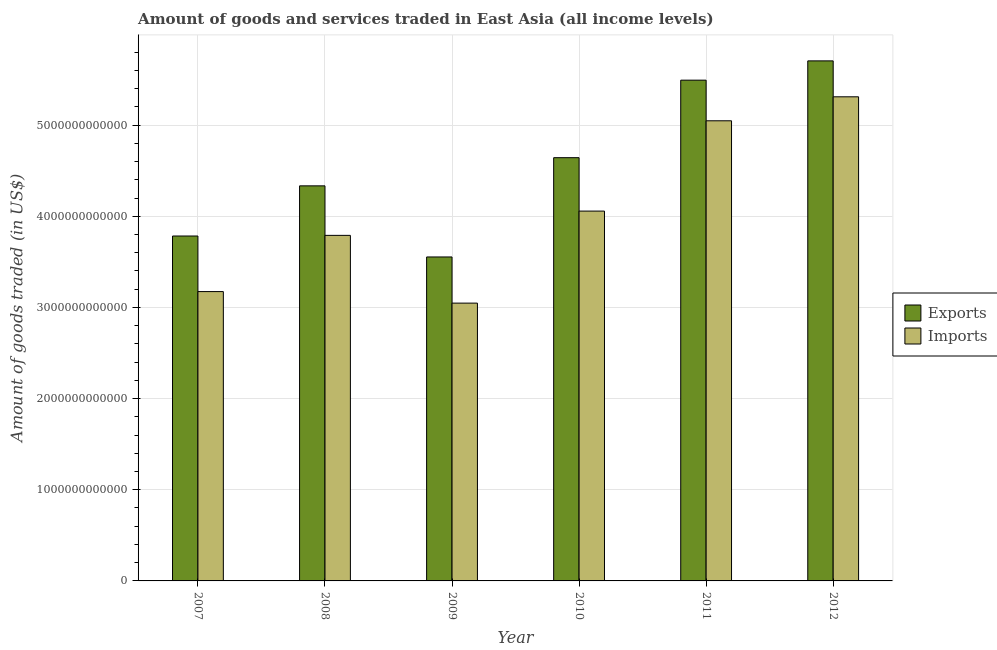How many bars are there on the 5th tick from the left?
Ensure brevity in your answer.  2. How many bars are there on the 6th tick from the right?
Make the answer very short. 2. What is the amount of goods exported in 2008?
Offer a terse response. 4.33e+12. Across all years, what is the maximum amount of goods imported?
Offer a terse response. 5.31e+12. Across all years, what is the minimum amount of goods imported?
Ensure brevity in your answer.  3.05e+12. In which year was the amount of goods imported minimum?
Offer a very short reply. 2009. What is the total amount of goods exported in the graph?
Offer a very short reply. 2.75e+13. What is the difference between the amount of goods imported in 2007 and that in 2011?
Give a very brief answer. -1.87e+12. What is the difference between the amount of goods imported in 2007 and the amount of goods exported in 2009?
Provide a short and direct response. 1.26e+11. What is the average amount of goods imported per year?
Your response must be concise. 4.07e+12. In how many years, is the amount of goods imported greater than 5400000000000 US$?
Give a very brief answer. 0. What is the ratio of the amount of goods imported in 2008 to that in 2009?
Make the answer very short. 1.24. Is the amount of goods imported in 2007 less than that in 2012?
Your answer should be very brief. Yes. What is the difference between the highest and the second highest amount of goods exported?
Ensure brevity in your answer.  2.12e+11. What is the difference between the highest and the lowest amount of goods exported?
Provide a short and direct response. 2.15e+12. In how many years, is the amount of goods exported greater than the average amount of goods exported taken over all years?
Provide a short and direct response. 3. What does the 2nd bar from the left in 2008 represents?
Your response must be concise. Imports. What does the 2nd bar from the right in 2011 represents?
Your response must be concise. Exports. Are all the bars in the graph horizontal?
Offer a very short reply. No. What is the difference between two consecutive major ticks on the Y-axis?
Ensure brevity in your answer.  1.00e+12. Are the values on the major ticks of Y-axis written in scientific E-notation?
Ensure brevity in your answer.  No. Does the graph contain any zero values?
Your answer should be compact. No. Where does the legend appear in the graph?
Offer a terse response. Center right. What is the title of the graph?
Offer a very short reply. Amount of goods and services traded in East Asia (all income levels). What is the label or title of the Y-axis?
Provide a succinct answer. Amount of goods traded (in US$). What is the Amount of goods traded (in US$) in Exports in 2007?
Offer a terse response. 3.78e+12. What is the Amount of goods traded (in US$) in Imports in 2007?
Ensure brevity in your answer.  3.17e+12. What is the Amount of goods traded (in US$) of Exports in 2008?
Ensure brevity in your answer.  4.33e+12. What is the Amount of goods traded (in US$) in Imports in 2008?
Your answer should be very brief. 3.79e+12. What is the Amount of goods traded (in US$) of Exports in 2009?
Ensure brevity in your answer.  3.55e+12. What is the Amount of goods traded (in US$) in Imports in 2009?
Ensure brevity in your answer.  3.05e+12. What is the Amount of goods traded (in US$) of Exports in 2010?
Provide a short and direct response. 4.64e+12. What is the Amount of goods traded (in US$) in Imports in 2010?
Provide a short and direct response. 4.06e+12. What is the Amount of goods traded (in US$) in Exports in 2011?
Offer a terse response. 5.49e+12. What is the Amount of goods traded (in US$) of Imports in 2011?
Your response must be concise. 5.05e+12. What is the Amount of goods traded (in US$) in Exports in 2012?
Provide a short and direct response. 5.70e+12. What is the Amount of goods traded (in US$) of Imports in 2012?
Ensure brevity in your answer.  5.31e+12. Across all years, what is the maximum Amount of goods traded (in US$) in Exports?
Provide a short and direct response. 5.70e+12. Across all years, what is the maximum Amount of goods traded (in US$) of Imports?
Your answer should be compact. 5.31e+12. Across all years, what is the minimum Amount of goods traded (in US$) of Exports?
Provide a succinct answer. 3.55e+12. Across all years, what is the minimum Amount of goods traded (in US$) in Imports?
Make the answer very short. 3.05e+12. What is the total Amount of goods traded (in US$) of Exports in the graph?
Offer a very short reply. 2.75e+13. What is the total Amount of goods traded (in US$) in Imports in the graph?
Your answer should be very brief. 2.44e+13. What is the difference between the Amount of goods traded (in US$) of Exports in 2007 and that in 2008?
Offer a terse response. -5.50e+11. What is the difference between the Amount of goods traded (in US$) in Imports in 2007 and that in 2008?
Offer a terse response. -6.17e+11. What is the difference between the Amount of goods traded (in US$) of Exports in 2007 and that in 2009?
Provide a succinct answer. 2.30e+11. What is the difference between the Amount of goods traded (in US$) in Imports in 2007 and that in 2009?
Your response must be concise. 1.26e+11. What is the difference between the Amount of goods traded (in US$) of Exports in 2007 and that in 2010?
Your response must be concise. -8.59e+11. What is the difference between the Amount of goods traded (in US$) of Imports in 2007 and that in 2010?
Keep it short and to the point. -8.83e+11. What is the difference between the Amount of goods traded (in US$) in Exports in 2007 and that in 2011?
Make the answer very short. -1.71e+12. What is the difference between the Amount of goods traded (in US$) in Imports in 2007 and that in 2011?
Offer a terse response. -1.87e+12. What is the difference between the Amount of goods traded (in US$) in Exports in 2007 and that in 2012?
Offer a terse response. -1.92e+12. What is the difference between the Amount of goods traded (in US$) of Imports in 2007 and that in 2012?
Offer a very short reply. -2.14e+12. What is the difference between the Amount of goods traded (in US$) of Exports in 2008 and that in 2009?
Provide a succinct answer. 7.80e+11. What is the difference between the Amount of goods traded (in US$) in Imports in 2008 and that in 2009?
Give a very brief answer. 7.43e+11. What is the difference between the Amount of goods traded (in US$) of Exports in 2008 and that in 2010?
Offer a terse response. -3.09e+11. What is the difference between the Amount of goods traded (in US$) in Imports in 2008 and that in 2010?
Ensure brevity in your answer.  -2.66e+11. What is the difference between the Amount of goods traded (in US$) of Exports in 2008 and that in 2011?
Your response must be concise. -1.16e+12. What is the difference between the Amount of goods traded (in US$) of Imports in 2008 and that in 2011?
Your response must be concise. -1.26e+12. What is the difference between the Amount of goods traded (in US$) in Exports in 2008 and that in 2012?
Your response must be concise. -1.37e+12. What is the difference between the Amount of goods traded (in US$) in Imports in 2008 and that in 2012?
Offer a terse response. -1.52e+12. What is the difference between the Amount of goods traded (in US$) in Exports in 2009 and that in 2010?
Your response must be concise. -1.09e+12. What is the difference between the Amount of goods traded (in US$) in Imports in 2009 and that in 2010?
Make the answer very short. -1.01e+12. What is the difference between the Amount of goods traded (in US$) of Exports in 2009 and that in 2011?
Offer a terse response. -1.94e+12. What is the difference between the Amount of goods traded (in US$) in Imports in 2009 and that in 2011?
Your answer should be compact. -2.00e+12. What is the difference between the Amount of goods traded (in US$) in Exports in 2009 and that in 2012?
Provide a succinct answer. -2.15e+12. What is the difference between the Amount of goods traded (in US$) in Imports in 2009 and that in 2012?
Make the answer very short. -2.26e+12. What is the difference between the Amount of goods traded (in US$) of Exports in 2010 and that in 2011?
Keep it short and to the point. -8.50e+11. What is the difference between the Amount of goods traded (in US$) of Imports in 2010 and that in 2011?
Make the answer very short. -9.90e+11. What is the difference between the Amount of goods traded (in US$) in Exports in 2010 and that in 2012?
Your answer should be very brief. -1.06e+12. What is the difference between the Amount of goods traded (in US$) in Imports in 2010 and that in 2012?
Make the answer very short. -1.25e+12. What is the difference between the Amount of goods traded (in US$) of Exports in 2011 and that in 2012?
Keep it short and to the point. -2.12e+11. What is the difference between the Amount of goods traded (in US$) in Imports in 2011 and that in 2012?
Your response must be concise. -2.63e+11. What is the difference between the Amount of goods traded (in US$) in Exports in 2007 and the Amount of goods traded (in US$) in Imports in 2008?
Make the answer very short. -7.04e+09. What is the difference between the Amount of goods traded (in US$) of Exports in 2007 and the Amount of goods traded (in US$) of Imports in 2009?
Your answer should be compact. 7.36e+11. What is the difference between the Amount of goods traded (in US$) of Exports in 2007 and the Amount of goods traded (in US$) of Imports in 2010?
Your response must be concise. -2.74e+11. What is the difference between the Amount of goods traded (in US$) in Exports in 2007 and the Amount of goods traded (in US$) in Imports in 2011?
Provide a short and direct response. -1.26e+12. What is the difference between the Amount of goods traded (in US$) in Exports in 2007 and the Amount of goods traded (in US$) in Imports in 2012?
Keep it short and to the point. -1.53e+12. What is the difference between the Amount of goods traded (in US$) of Exports in 2008 and the Amount of goods traded (in US$) of Imports in 2009?
Your answer should be very brief. 1.29e+12. What is the difference between the Amount of goods traded (in US$) of Exports in 2008 and the Amount of goods traded (in US$) of Imports in 2010?
Keep it short and to the point. 2.77e+11. What is the difference between the Amount of goods traded (in US$) of Exports in 2008 and the Amount of goods traded (in US$) of Imports in 2011?
Your answer should be compact. -7.14e+11. What is the difference between the Amount of goods traded (in US$) in Exports in 2008 and the Amount of goods traded (in US$) in Imports in 2012?
Offer a terse response. -9.77e+11. What is the difference between the Amount of goods traded (in US$) in Exports in 2009 and the Amount of goods traded (in US$) in Imports in 2010?
Offer a very short reply. -5.03e+11. What is the difference between the Amount of goods traded (in US$) of Exports in 2009 and the Amount of goods traded (in US$) of Imports in 2011?
Your response must be concise. -1.49e+12. What is the difference between the Amount of goods traded (in US$) in Exports in 2009 and the Amount of goods traded (in US$) in Imports in 2012?
Ensure brevity in your answer.  -1.76e+12. What is the difference between the Amount of goods traded (in US$) in Exports in 2010 and the Amount of goods traded (in US$) in Imports in 2011?
Offer a very short reply. -4.05e+11. What is the difference between the Amount of goods traded (in US$) in Exports in 2010 and the Amount of goods traded (in US$) in Imports in 2012?
Provide a succinct answer. -6.68e+11. What is the difference between the Amount of goods traded (in US$) in Exports in 2011 and the Amount of goods traded (in US$) in Imports in 2012?
Give a very brief answer. 1.82e+11. What is the average Amount of goods traded (in US$) in Exports per year?
Keep it short and to the point. 4.59e+12. What is the average Amount of goods traded (in US$) in Imports per year?
Give a very brief answer. 4.07e+12. In the year 2007, what is the difference between the Amount of goods traded (in US$) of Exports and Amount of goods traded (in US$) of Imports?
Offer a very short reply. 6.09e+11. In the year 2008, what is the difference between the Amount of goods traded (in US$) in Exports and Amount of goods traded (in US$) in Imports?
Make the answer very short. 5.43e+11. In the year 2009, what is the difference between the Amount of goods traded (in US$) in Exports and Amount of goods traded (in US$) in Imports?
Give a very brief answer. 5.06e+11. In the year 2010, what is the difference between the Amount of goods traded (in US$) in Exports and Amount of goods traded (in US$) in Imports?
Your answer should be very brief. 5.86e+11. In the year 2011, what is the difference between the Amount of goods traded (in US$) of Exports and Amount of goods traded (in US$) of Imports?
Offer a terse response. 4.46e+11. In the year 2012, what is the difference between the Amount of goods traded (in US$) in Exports and Amount of goods traded (in US$) in Imports?
Your response must be concise. 3.94e+11. What is the ratio of the Amount of goods traded (in US$) of Exports in 2007 to that in 2008?
Your answer should be compact. 0.87. What is the ratio of the Amount of goods traded (in US$) of Imports in 2007 to that in 2008?
Keep it short and to the point. 0.84. What is the ratio of the Amount of goods traded (in US$) in Exports in 2007 to that in 2009?
Your answer should be very brief. 1.06. What is the ratio of the Amount of goods traded (in US$) of Imports in 2007 to that in 2009?
Your response must be concise. 1.04. What is the ratio of the Amount of goods traded (in US$) in Exports in 2007 to that in 2010?
Offer a terse response. 0.81. What is the ratio of the Amount of goods traded (in US$) in Imports in 2007 to that in 2010?
Provide a short and direct response. 0.78. What is the ratio of the Amount of goods traded (in US$) in Exports in 2007 to that in 2011?
Your answer should be very brief. 0.69. What is the ratio of the Amount of goods traded (in US$) in Imports in 2007 to that in 2011?
Your answer should be compact. 0.63. What is the ratio of the Amount of goods traded (in US$) of Exports in 2007 to that in 2012?
Provide a succinct answer. 0.66. What is the ratio of the Amount of goods traded (in US$) in Imports in 2007 to that in 2012?
Provide a short and direct response. 0.6. What is the ratio of the Amount of goods traded (in US$) in Exports in 2008 to that in 2009?
Provide a short and direct response. 1.22. What is the ratio of the Amount of goods traded (in US$) in Imports in 2008 to that in 2009?
Your response must be concise. 1.24. What is the ratio of the Amount of goods traded (in US$) of Exports in 2008 to that in 2010?
Offer a terse response. 0.93. What is the ratio of the Amount of goods traded (in US$) in Imports in 2008 to that in 2010?
Provide a short and direct response. 0.93. What is the ratio of the Amount of goods traded (in US$) in Exports in 2008 to that in 2011?
Your answer should be very brief. 0.79. What is the ratio of the Amount of goods traded (in US$) of Imports in 2008 to that in 2011?
Offer a very short reply. 0.75. What is the ratio of the Amount of goods traded (in US$) of Exports in 2008 to that in 2012?
Provide a succinct answer. 0.76. What is the ratio of the Amount of goods traded (in US$) in Imports in 2008 to that in 2012?
Give a very brief answer. 0.71. What is the ratio of the Amount of goods traded (in US$) of Exports in 2009 to that in 2010?
Make the answer very short. 0.77. What is the ratio of the Amount of goods traded (in US$) of Imports in 2009 to that in 2010?
Provide a short and direct response. 0.75. What is the ratio of the Amount of goods traded (in US$) of Exports in 2009 to that in 2011?
Make the answer very short. 0.65. What is the ratio of the Amount of goods traded (in US$) in Imports in 2009 to that in 2011?
Ensure brevity in your answer.  0.6. What is the ratio of the Amount of goods traded (in US$) of Exports in 2009 to that in 2012?
Ensure brevity in your answer.  0.62. What is the ratio of the Amount of goods traded (in US$) in Imports in 2009 to that in 2012?
Offer a terse response. 0.57. What is the ratio of the Amount of goods traded (in US$) in Exports in 2010 to that in 2011?
Provide a short and direct response. 0.85. What is the ratio of the Amount of goods traded (in US$) in Imports in 2010 to that in 2011?
Your response must be concise. 0.8. What is the ratio of the Amount of goods traded (in US$) of Exports in 2010 to that in 2012?
Provide a succinct answer. 0.81. What is the ratio of the Amount of goods traded (in US$) in Imports in 2010 to that in 2012?
Make the answer very short. 0.76. What is the ratio of the Amount of goods traded (in US$) of Exports in 2011 to that in 2012?
Ensure brevity in your answer.  0.96. What is the ratio of the Amount of goods traded (in US$) of Imports in 2011 to that in 2012?
Provide a succinct answer. 0.95. What is the difference between the highest and the second highest Amount of goods traded (in US$) of Exports?
Provide a short and direct response. 2.12e+11. What is the difference between the highest and the second highest Amount of goods traded (in US$) in Imports?
Give a very brief answer. 2.63e+11. What is the difference between the highest and the lowest Amount of goods traded (in US$) of Exports?
Ensure brevity in your answer.  2.15e+12. What is the difference between the highest and the lowest Amount of goods traded (in US$) of Imports?
Give a very brief answer. 2.26e+12. 